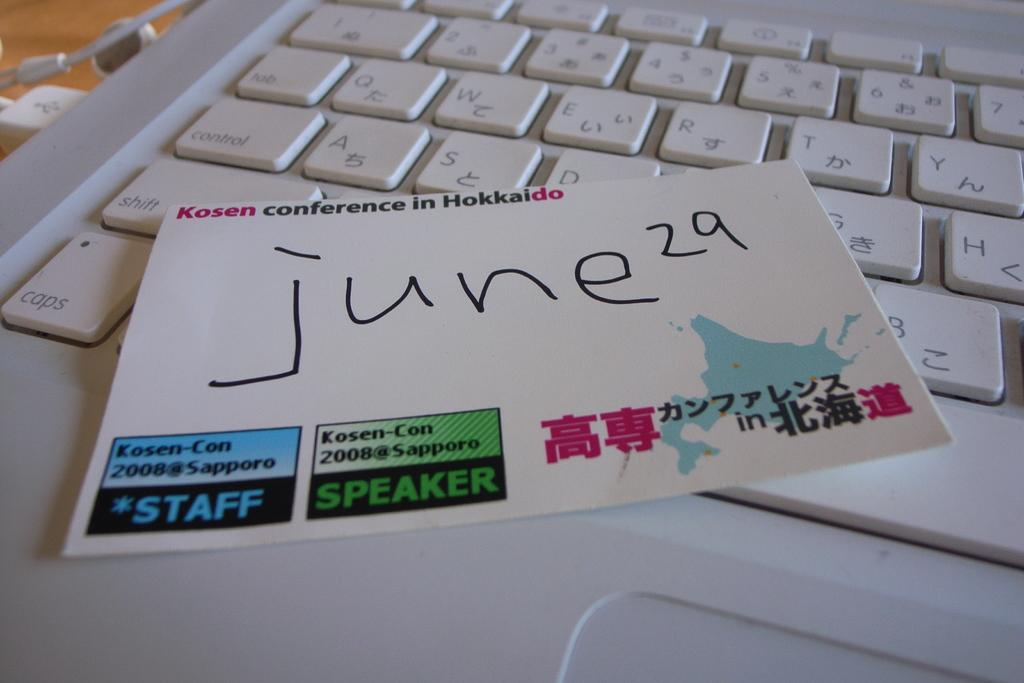Provide a one-sentence caption for the provided image. A note from the 2008 Kosen Conference with a handwritten date on top of a laptop keyboard. 